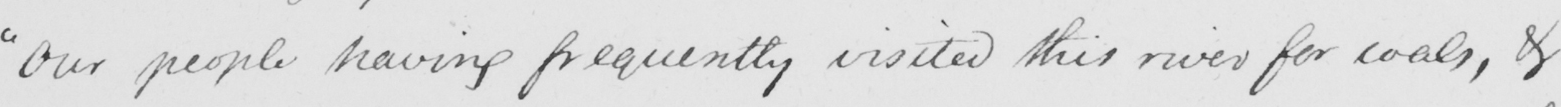What is written in this line of handwriting? " Our people having frequently visited this river for coals , & 